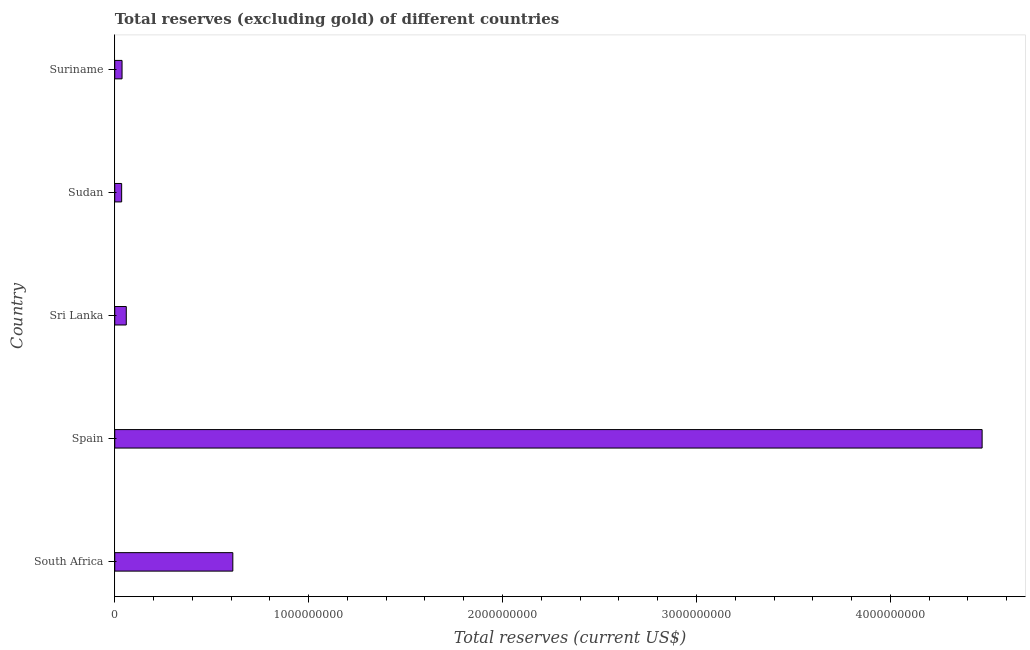Does the graph contain grids?
Offer a very short reply. No. What is the title of the graph?
Keep it short and to the point. Total reserves (excluding gold) of different countries. What is the label or title of the X-axis?
Keep it short and to the point. Total reserves (current US$). What is the label or title of the Y-axis?
Provide a short and direct response. Country. What is the total reserves (excluding gold) in Sudan?
Keep it short and to the point. 3.56e+07. Across all countries, what is the maximum total reserves (excluding gold)?
Make the answer very short. 4.47e+09. Across all countries, what is the minimum total reserves (excluding gold)?
Keep it short and to the point. 3.56e+07. In which country was the total reserves (excluding gold) minimum?
Provide a succinct answer. Sudan. What is the sum of the total reserves (excluding gold)?
Offer a terse response. 5.21e+09. What is the difference between the total reserves (excluding gold) in Spain and Sudan?
Give a very brief answer. 4.44e+09. What is the average total reserves (excluding gold) per country?
Ensure brevity in your answer.  1.04e+09. What is the median total reserves (excluding gold)?
Ensure brevity in your answer.  5.95e+07. What is the ratio of the total reserves (excluding gold) in Sudan to that in Suriname?
Your response must be concise. 0.95. What is the difference between the highest and the second highest total reserves (excluding gold)?
Give a very brief answer. 3.86e+09. What is the difference between the highest and the lowest total reserves (excluding gold)?
Your answer should be compact. 4.44e+09. Are all the bars in the graph horizontal?
Your response must be concise. Yes. How many countries are there in the graph?
Your answer should be compact. 5. Are the values on the major ticks of X-axis written in scientific E-notation?
Keep it short and to the point. No. What is the Total reserves (current US$) in South Africa?
Your answer should be compact. 6.09e+08. What is the Total reserves (current US$) of Spain?
Offer a terse response. 4.47e+09. What is the Total reserves (current US$) of Sri Lanka?
Provide a succinct answer. 5.95e+07. What is the Total reserves (current US$) of Sudan?
Ensure brevity in your answer.  3.56e+07. What is the Total reserves (current US$) of Suriname?
Ensure brevity in your answer.  3.76e+07. What is the difference between the Total reserves (current US$) in South Africa and Spain?
Make the answer very short. -3.86e+09. What is the difference between the Total reserves (current US$) in South Africa and Sri Lanka?
Provide a succinct answer. 5.49e+08. What is the difference between the Total reserves (current US$) in South Africa and Sudan?
Give a very brief answer. 5.73e+08. What is the difference between the Total reserves (current US$) in South Africa and Suriname?
Offer a very short reply. 5.71e+08. What is the difference between the Total reserves (current US$) in Spain and Sri Lanka?
Make the answer very short. 4.41e+09. What is the difference between the Total reserves (current US$) in Spain and Sudan?
Your answer should be compact. 4.44e+09. What is the difference between the Total reserves (current US$) in Spain and Suriname?
Provide a short and direct response. 4.44e+09. What is the difference between the Total reserves (current US$) in Sri Lanka and Sudan?
Keep it short and to the point. 2.39e+07. What is the difference between the Total reserves (current US$) in Sri Lanka and Suriname?
Your answer should be compact. 2.19e+07. What is the difference between the Total reserves (current US$) in Sudan and Suriname?
Offer a terse response. -2.00e+06. What is the ratio of the Total reserves (current US$) in South Africa to that in Spain?
Offer a terse response. 0.14. What is the ratio of the Total reserves (current US$) in South Africa to that in Sri Lanka?
Make the answer very short. 10.24. What is the ratio of the Total reserves (current US$) in South Africa to that in Sudan?
Keep it short and to the point. 17.11. What is the ratio of the Total reserves (current US$) in South Africa to that in Suriname?
Ensure brevity in your answer.  16.2. What is the ratio of the Total reserves (current US$) in Spain to that in Sri Lanka?
Ensure brevity in your answer.  75.23. What is the ratio of the Total reserves (current US$) in Spain to that in Sudan?
Give a very brief answer. 125.7. What is the ratio of the Total reserves (current US$) in Spain to that in Suriname?
Make the answer very short. 119. What is the ratio of the Total reserves (current US$) in Sri Lanka to that in Sudan?
Provide a short and direct response. 1.67. What is the ratio of the Total reserves (current US$) in Sri Lanka to that in Suriname?
Offer a very short reply. 1.58. What is the ratio of the Total reserves (current US$) in Sudan to that in Suriname?
Ensure brevity in your answer.  0.95. 